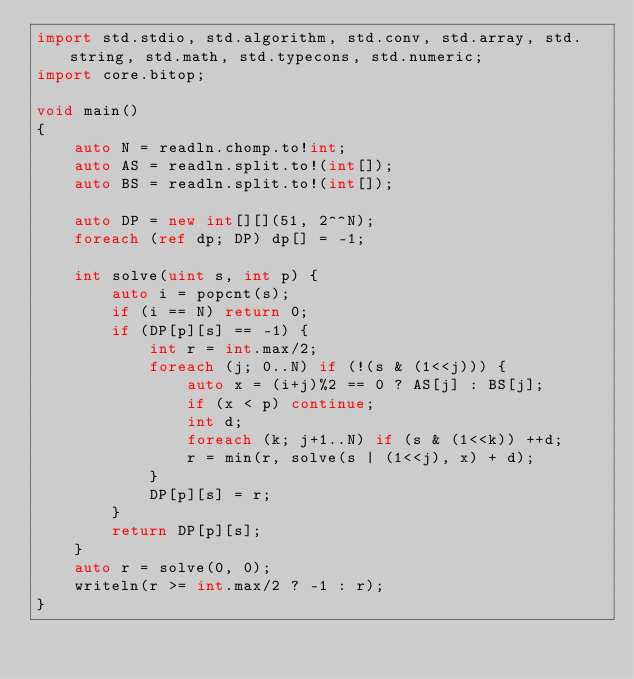<code> <loc_0><loc_0><loc_500><loc_500><_D_>import std.stdio, std.algorithm, std.conv, std.array, std.string, std.math, std.typecons, std.numeric;
import core.bitop;

void main()
{
    auto N = readln.chomp.to!int;
    auto AS = readln.split.to!(int[]);
    auto BS = readln.split.to!(int[]);

    auto DP = new int[][](51, 2^^N);
    foreach (ref dp; DP) dp[] = -1;

    int solve(uint s, int p) {
        auto i = popcnt(s);
        if (i == N) return 0;
        if (DP[p][s] == -1) {
            int r = int.max/2;
            foreach (j; 0..N) if (!(s & (1<<j))) {
                auto x = (i+j)%2 == 0 ? AS[j] : BS[j];
                if (x < p) continue;
                int d;
                foreach (k; j+1..N) if (s & (1<<k)) ++d;
                r = min(r, solve(s | (1<<j), x) + d);
            }
            DP[p][s] = r;
        }
        return DP[p][s];
    }
    auto r = solve(0, 0);
    writeln(r >= int.max/2 ? -1 : r);
}</code> 